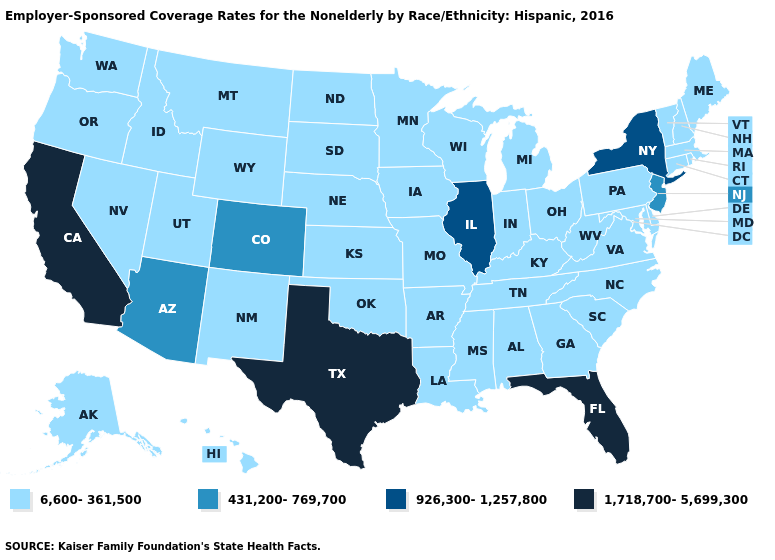What is the lowest value in the USA?
Be succinct. 6,600-361,500. Among the states that border New York , does Connecticut have the lowest value?
Give a very brief answer. Yes. Does Illinois have the lowest value in the MidWest?
Write a very short answer. No. Which states hav the highest value in the South?
Short answer required. Florida, Texas. What is the value of Connecticut?
Keep it brief. 6,600-361,500. Name the states that have a value in the range 6,600-361,500?
Quick response, please. Alabama, Alaska, Arkansas, Connecticut, Delaware, Georgia, Hawaii, Idaho, Indiana, Iowa, Kansas, Kentucky, Louisiana, Maine, Maryland, Massachusetts, Michigan, Minnesota, Mississippi, Missouri, Montana, Nebraska, Nevada, New Hampshire, New Mexico, North Carolina, North Dakota, Ohio, Oklahoma, Oregon, Pennsylvania, Rhode Island, South Carolina, South Dakota, Tennessee, Utah, Vermont, Virginia, Washington, West Virginia, Wisconsin, Wyoming. Which states have the highest value in the USA?
Be succinct. California, Florida, Texas. Does the first symbol in the legend represent the smallest category?
Answer briefly. Yes. What is the lowest value in states that border Washington?
Keep it brief. 6,600-361,500. Does Illinois have the highest value in the MidWest?
Concise answer only. Yes. Does Arkansas have a lower value than Kentucky?
Keep it brief. No. What is the lowest value in the USA?
Short answer required. 6,600-361,500. Does Delaware have the same value as Michigan?
Give a very brief answer. Yes. What is the value of Michigan?
Short answer required. 6,600-361,500. Name the states that have a value in the range 431,200-769,700?
Be succinct. Arizona, Colorado, New Jersey. 